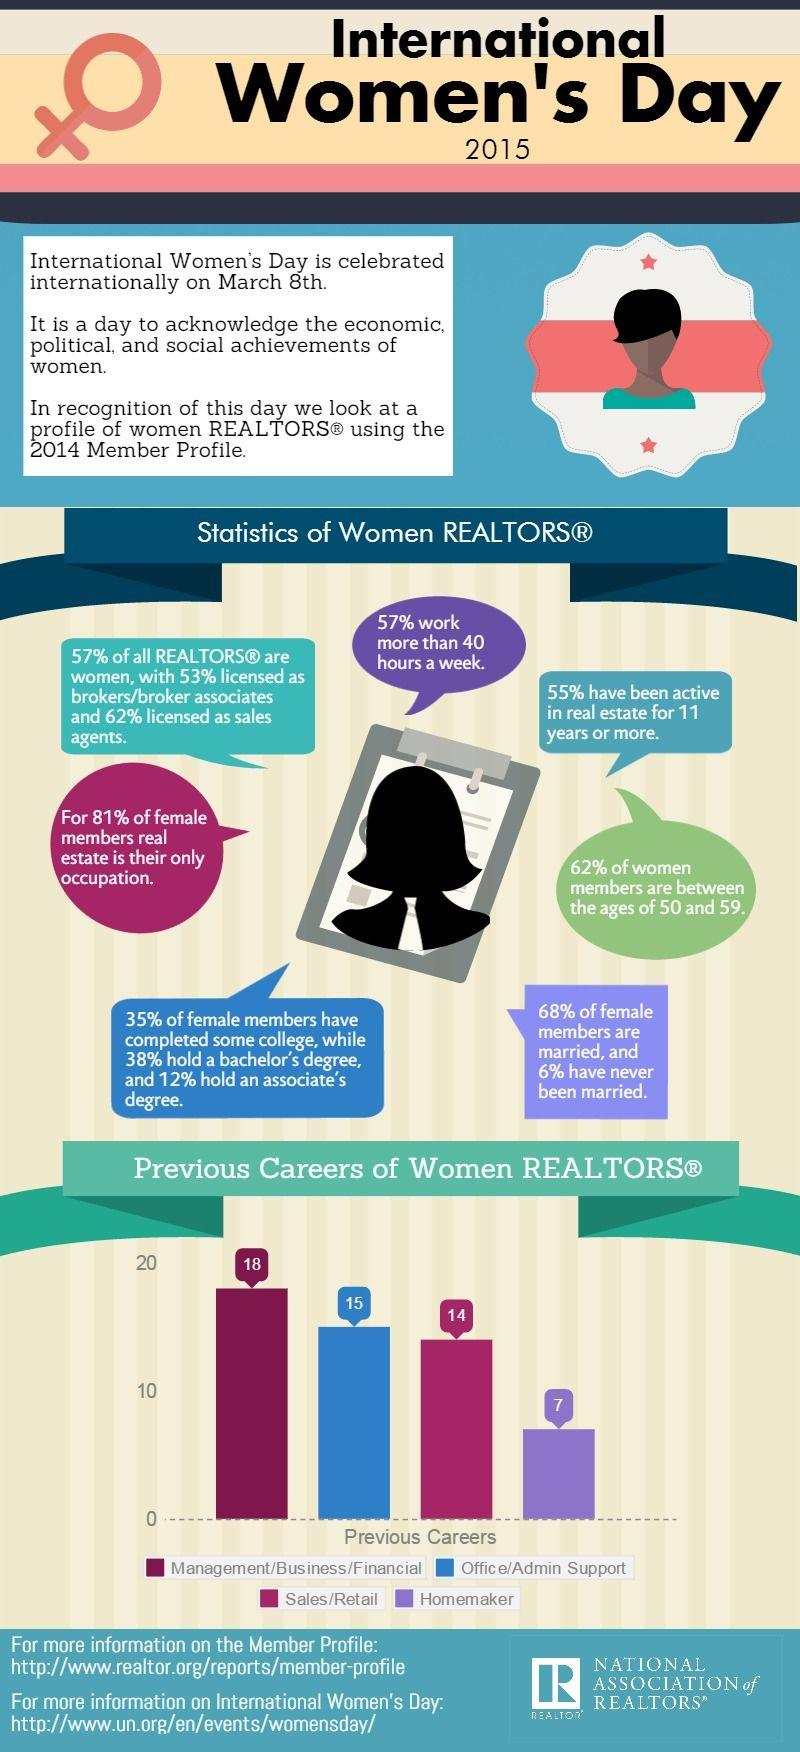List a handful of essential elements in this visual. The majority of female realtors have previously had careers in management, business, and finance. According to the graph, approximately 15% of women were employed in office/admin support. 